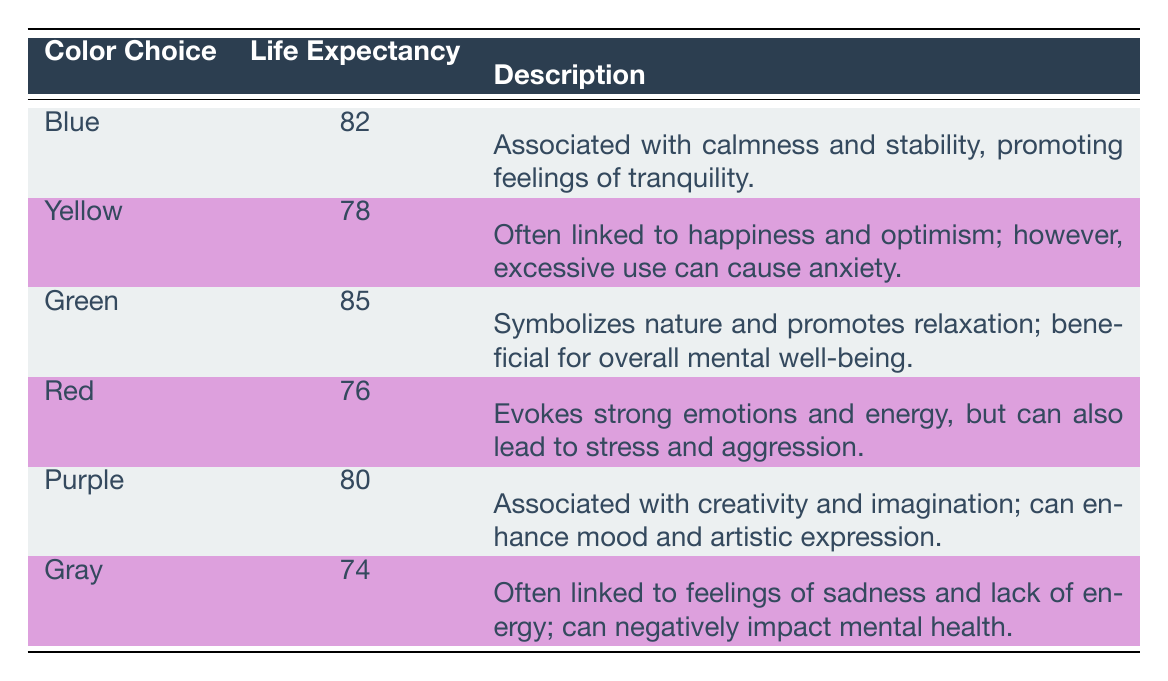What is the life expectancy associated with the color choice "Green"? The table directly provides the life expectancy for "Green," which is noted as 85.
Answer: 85 Which color choice has the highest mental health rating? By comparing the mental health ratings in the table, "Green" has the highest rating of 8.8.
Answer: Green What is the average life expectancy of designers who prefer "Red" and "Gray"? The life expectancies for "Red" and "Gray" are 76 and 74, respectively. Adding these gives 150, and dividing by 2 gives an average of 75.
Answer: 75 Is the mental health rating for "Blue" higher than that of "Yellow"? The mental health rating for "Blue" is 8.5, and for "Yellow" it is 7.2. Since 8.5 is greater than 7.2, the statement is true.
Answer: Yes What is the life expectancy difference between those who prefer "Blue" and those who prefer "Red"? The life expectancy for "Blue" is 82 and for "Red" is 76. The difference is 82 - 76 = 6.
Answer: 6 How many color choices have a life expectancy of 80 or higher? The color choices with a life expectancy of 80 or higher are "Blue" (82), "Green" (85), and "Purple" (80). In total, there are three color choices.
Answer: 3 Does the description for "Gray" suggest a positive influence on mental health? The description for "Gray" states it is linked to feelings of sadness and lack of energy, implying a negative influence. Thus, it is false that it suggests a positive influence.
Answer: No Which two colors have the closest mental health ratings? The ratings for "Purple" (7.8) and "Yellow" (7.2) are the closest values. The difference between them is 0.6, indicating proximity.
Answer: Purple and Yellow 